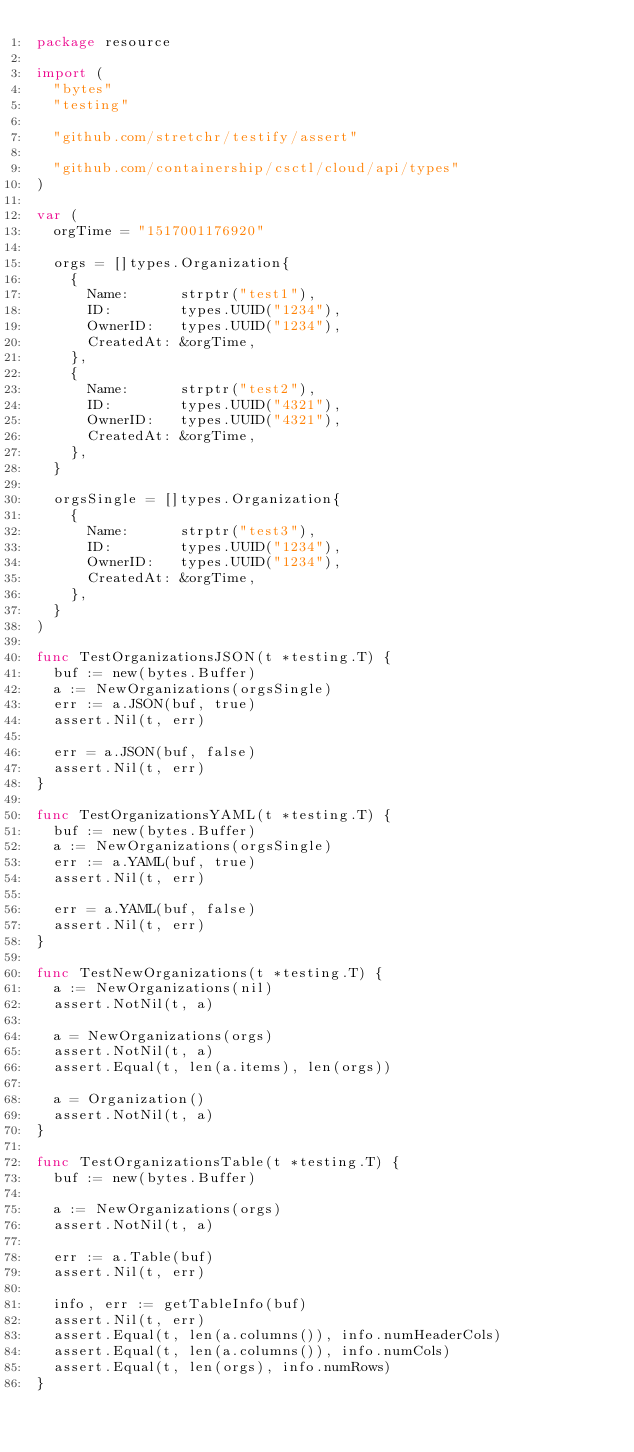<code> <loc_0><loc_0><loc_500><loc_500><_Go_>package resource

import (
	"bytes"
	"testing"

	"github.com/stretchr/testify/assert"

	"github.com/containership/csctl/cloud/api/types"
)

var (
	orgTime = "1517001176920"

	orgs = []types.Organization{
		{
			Name:      strptr("test1"),
			ID:        types.UUID("1234"),
			OwnerID:   types.UUID("1234"),
			CreatedAt: &orgTime,
		},
		{
			Name:      strptr("test2"),
			ID:        types.UUID("4321"),
			OwnerID:   types.UUID("4321"),
			CreatedAt: &orgTime,
		},
	}

	orgsSingle = []types.Organization{
		{
			Name:      strptr("test3"),
			ID:        types.UUID("1234"),
			OwnerID:   types.UUID("1234"),
			CreatedAt: &orgTime,
		},
	}
)

func TestOrganizationsJSON(t *testing.T) {
	buf := new(bytes.Buffer)
	a := NewOrganizations(orgsSingle)
	err := a.JSON(buf, true)
	assert.Nil(t, err)

	err = a.JSON(buf, false)
	assert.Nil(t, err)
}

func TestOrganizationsYAML(t *testing.T) {
	buf := new(bytes.Buffer)
	a := NewOrganizations(orgsSingle)
	err := a.YAML(buf, true)
	assert.Nil(t, err)

	err = a.YAML(buf, false)
	assert.Nil(t, err)
}

func TestNewOrganizations(t *testing.T) {
	a := NewOrganizations(nil)
	assert.NotNil(t, a)

	a = NewOrganizations(orgs)
	assert.NotNil(t, a)
	assert.Equal(t, len(a.items), len(orgs))

	a = Organization()
	assert.NotNil(t, a)
}

func TestOrganizationsTable(t *testing.T) {
	buf := new(bytes.Buffer)

	a := NewOrganizations(orgs)
	assert.NotNil(t, a)

	err := a.Table(buf)
	assert.Nil(t, err)

	info, err := getTableInfo(buf)
	assert.Nil(t, err)
	assert.Equal(t, len(a.columns()), info.numHeaderCols)
	assert.Equal(t, len(a.columns()), info.numCols)
	assert.Equal(t, len(orgs), info.numRows)
}
</code> 